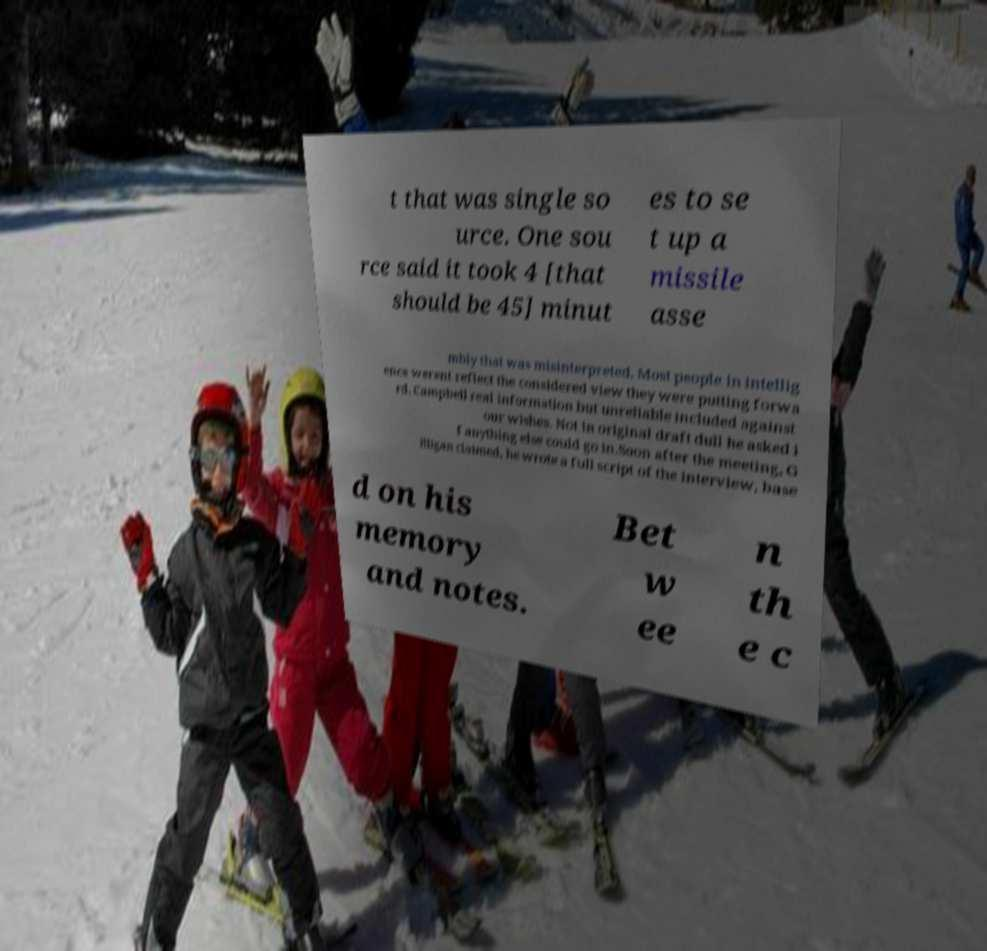Please identify and transcribe the text found in this image. t that was single so urce. One sou rce said it took 4 [that should be 45] minut es to se t up a missile asse mbly that was misinterpreted. Most people in intellig ence werent reflect the considered view they were putting forwa rd. Campbell real information but unreliable included against our wishes. Not in original draft dull he asked i f anything else could go in.Soon after the meeting, G illigan claimed, he wrote a full script of the interview, base d on his memory and notes. Bet w ee n th e c 